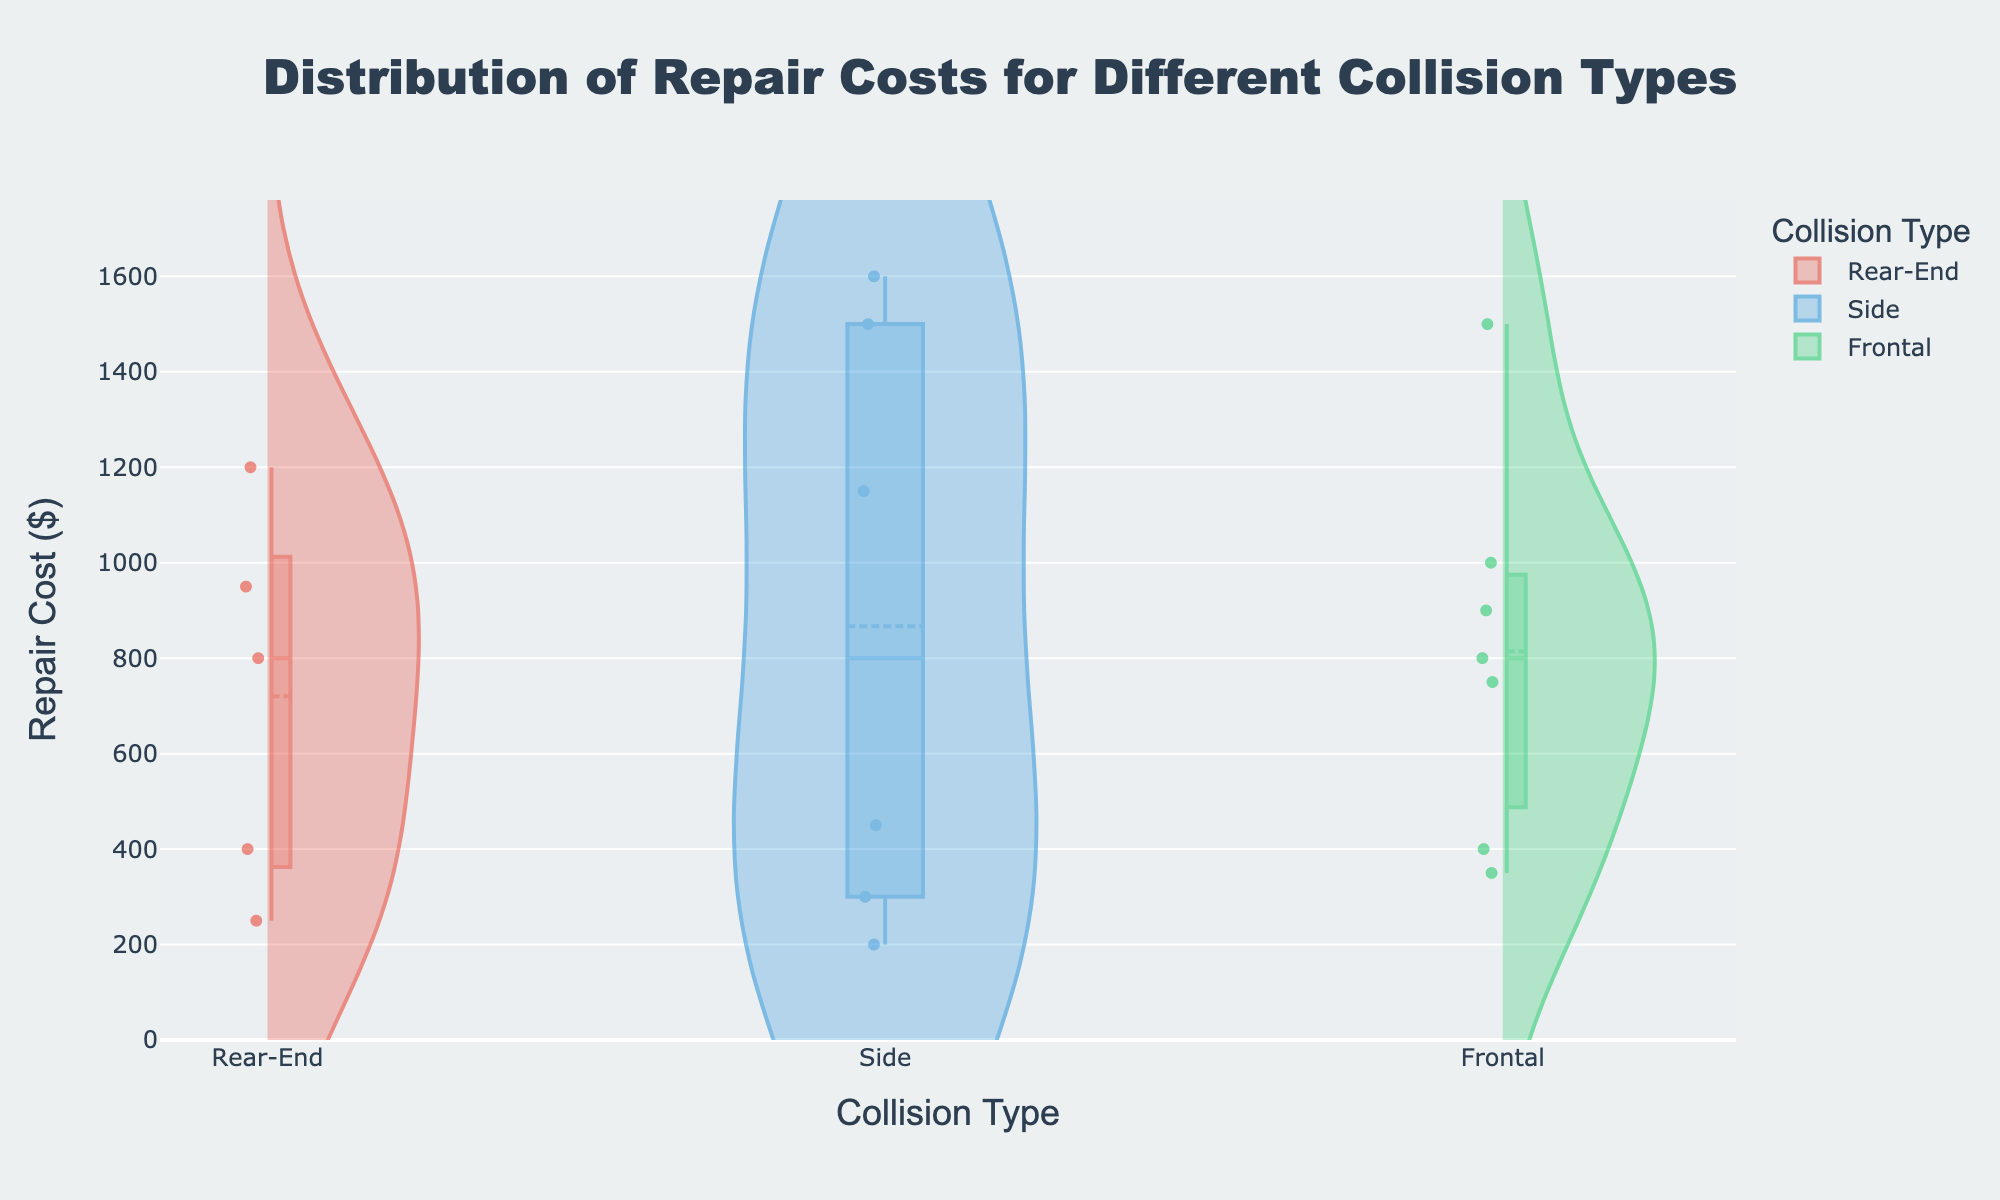What is the title of the figure? The title is centered at the top of the figure and can be read easily as 'Distribution of Repair Costs for Different Collision Types'.
Answer: Distribution of Repair Costs for Different Collision Types Which collision type has the highest maximum repair cost? By looking at the highest points in the plots, the collision type 'Side' reaches the highest on the y-axis, indicating the highest maximum repair cost.
Answer: Side What is the repair cost range for the Rear-End collision type? To determine the range, look at the lowest and highest points on the y-axis for the 'Rear-End' violin plot. The range spans from approximately 250 to 1200 dollars.
Answer: 250 to 1200 dollars Between Rear-End and Frontal collision types, which has a higher median repair cost? The median is often shown by a thick line in the violin plot. The 'Frontal' violin has its median line higher than the 'Rear-End', indicating a higher median repair cost for frontal collisions.
Answer: Frontal How many distinct repair costs are visualized for the Frontal collision type? Each point within the 'Frontal' violin plot represents a distinct repair cost. Counting these within the plot, there are 7 points visible.
Answer: 7 Which collision type has the narrowest distribution of repair costs? The 'Rear-End' violin plot appears the most compact in terms of the spread of costs on the y-axis, indicating the narrowest distribution.
Answer: Rear-End What is the average repair cost for the Side collision type? To find the average, sum the repair costs for Side collisions (1500 + 300 + 450 + 1600 + 200 + 1150) and divide by the number of costs. (1500 + 300 + 450 + 1600 + 200 + 1150) / 6 = 5200 / 6 = approximately 866.67.
Answer: approximately 866.67 Compare the distributions of repair costs for Rear-End and Frontal collisions. Which type has a larger spread? Spread is visualized by the width of the distribution. 'Frontal' repairs spread wider horizontally in the plot than 'Rear-End' repairs, indicating a larger distribution spread.
Answer: Frontal Which repair cost appears most frequently for Rear-End collisions? The density of the violin is highest around the 800 dollars mark for the 'Rear-End' collisions, indicating this cost appears most frequently.
Answer: 800 dollars What can be inferred about the symmetry of the repair cost distributions in the plots? The symmetry can be seen in how evenly the costs are distributed above and below the median. 'Side' collisions show the most asymmetrical distribution with more repair costs on the higher side, while 'Rear-End' and 'Frontal' are more symmetrical.
Answer: Side is asymmetric; Rear-End and Frontal are more symmetric 